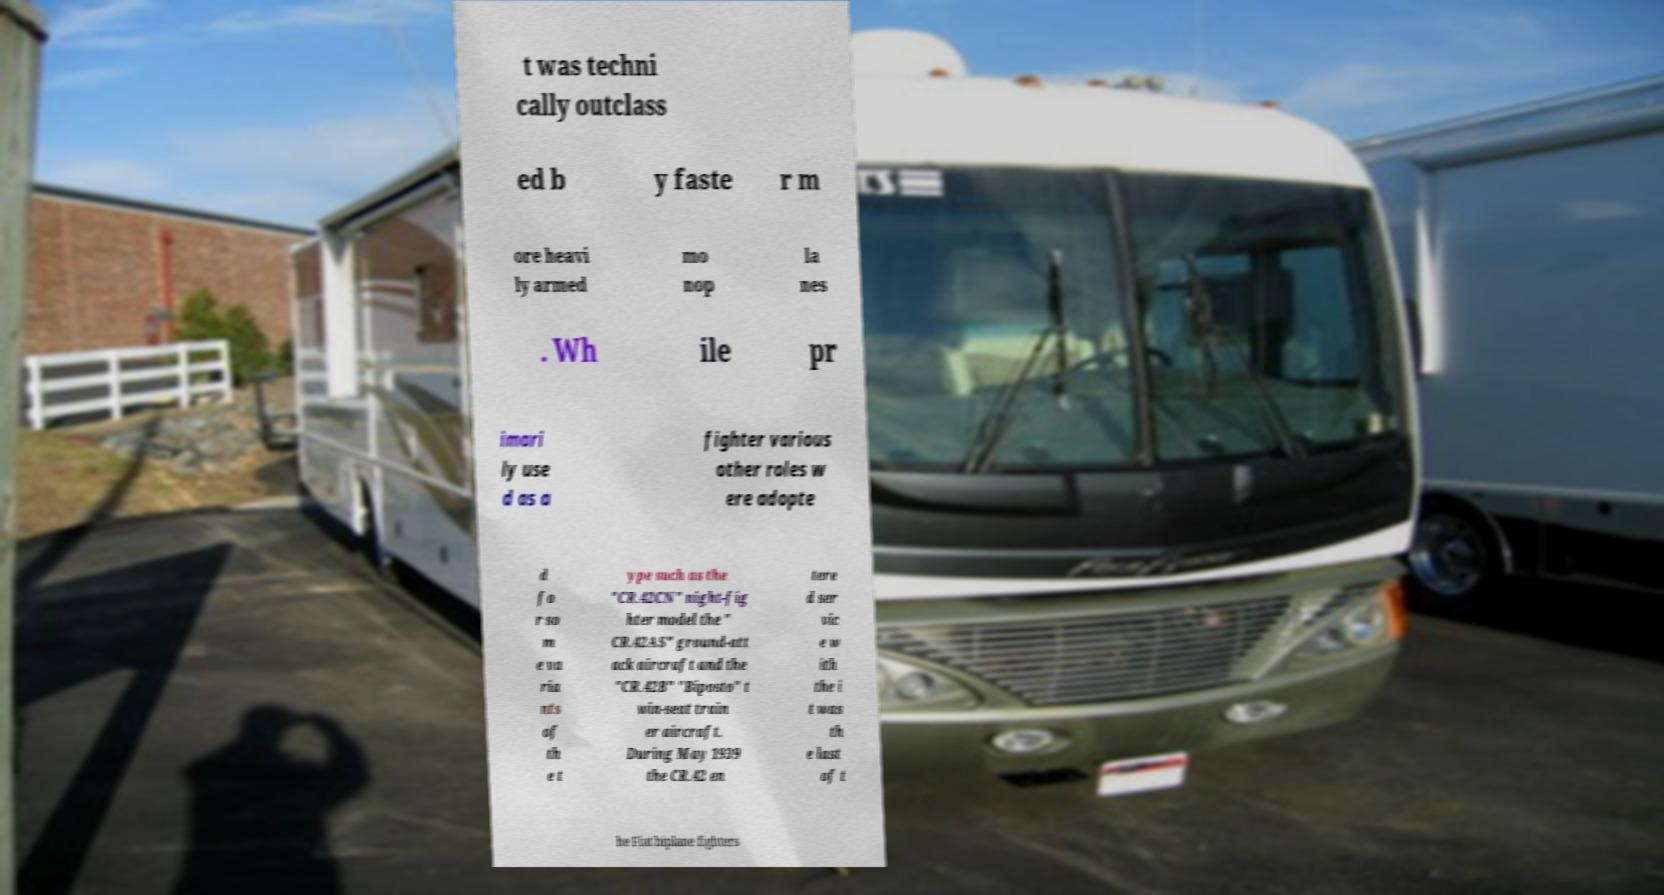Could you extract and type out the text from this image? t was techni cally outclass ed b y faste r m ore heavi ly armed mo nop la nes . Wh ile pr imari ly use d as a fighter various other roles w ere adopte d fo r so m e va ria nts of th e t ype such as the "CR.42CN" night-fig hter model the " CR.42AS" ground-att ack aircraft and the "CR.42B" "Biposto" t win-seat train er aircraft. During May 1939 the CR.42 en tere d ser vic e w ith the i t was th e last of t he Fiat biplane fighters 